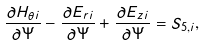<formula> <loc_0><loc_0><loc_500><loc_500>\frac { \partial H _ { \theta i } } { \partial \Psi } - \frac { \partial E _ { r i } } { \partial \Psi } + \frac { \partial E _ { z i } } { \partial \Psi } = S _ { 5 , i } ,</formula> 